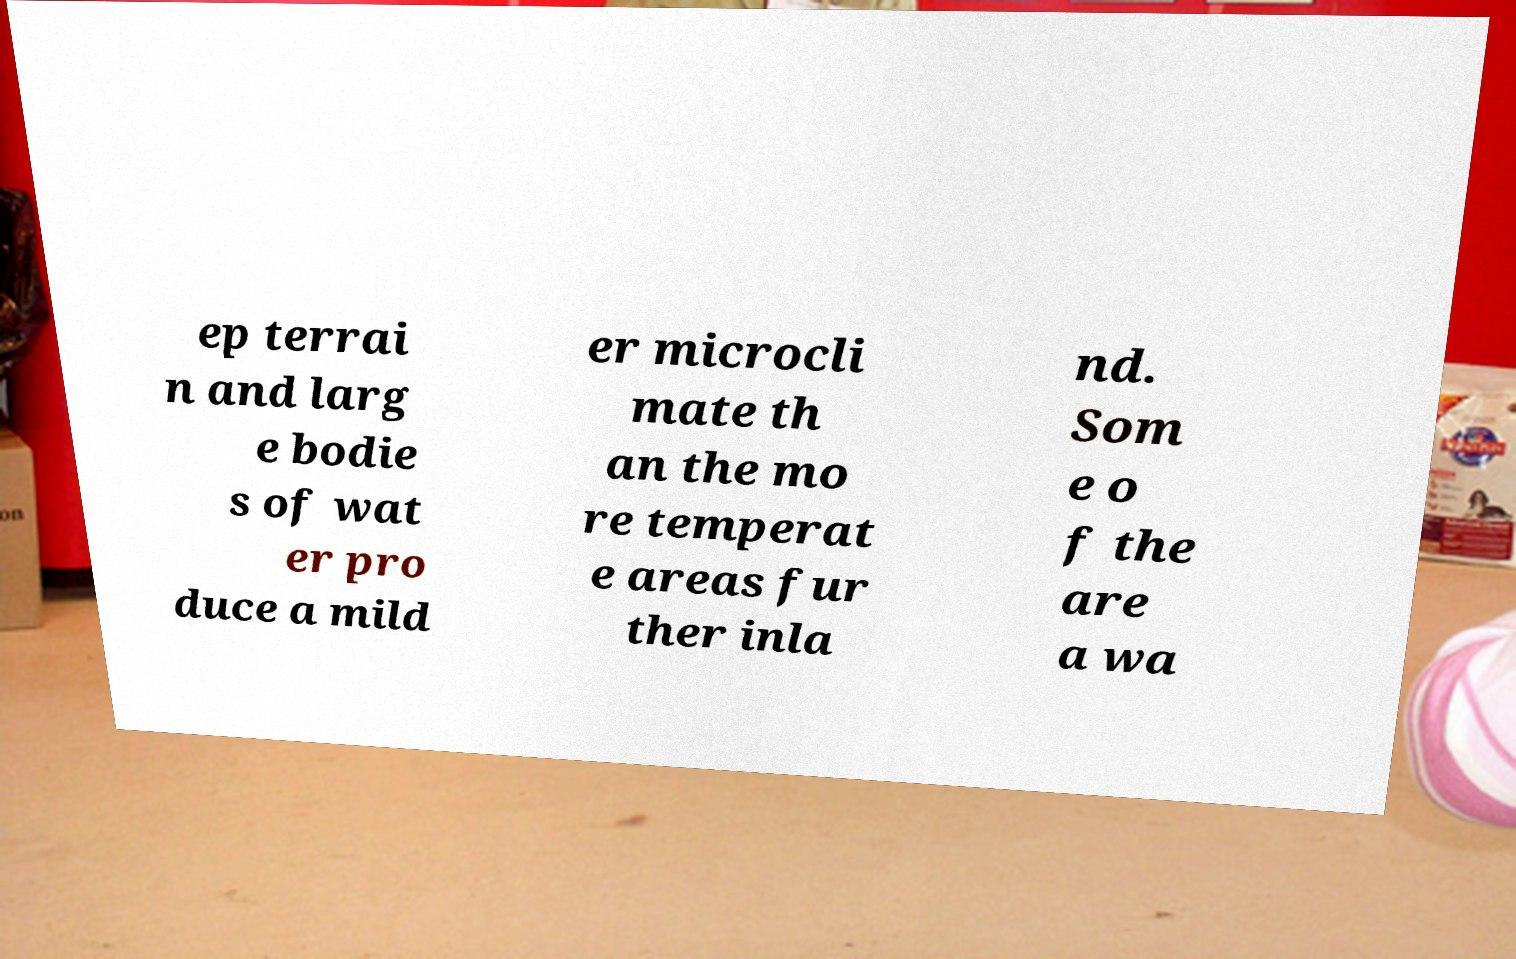There's text embedded in this image that I need extracted. Can you transcribe it verbatim? ep terrai n and larg e bodie s of wat er pro duce a mild er microcli mate th an the mo re temperat e areas fur ther inla nd. Som e o f the are a wa 